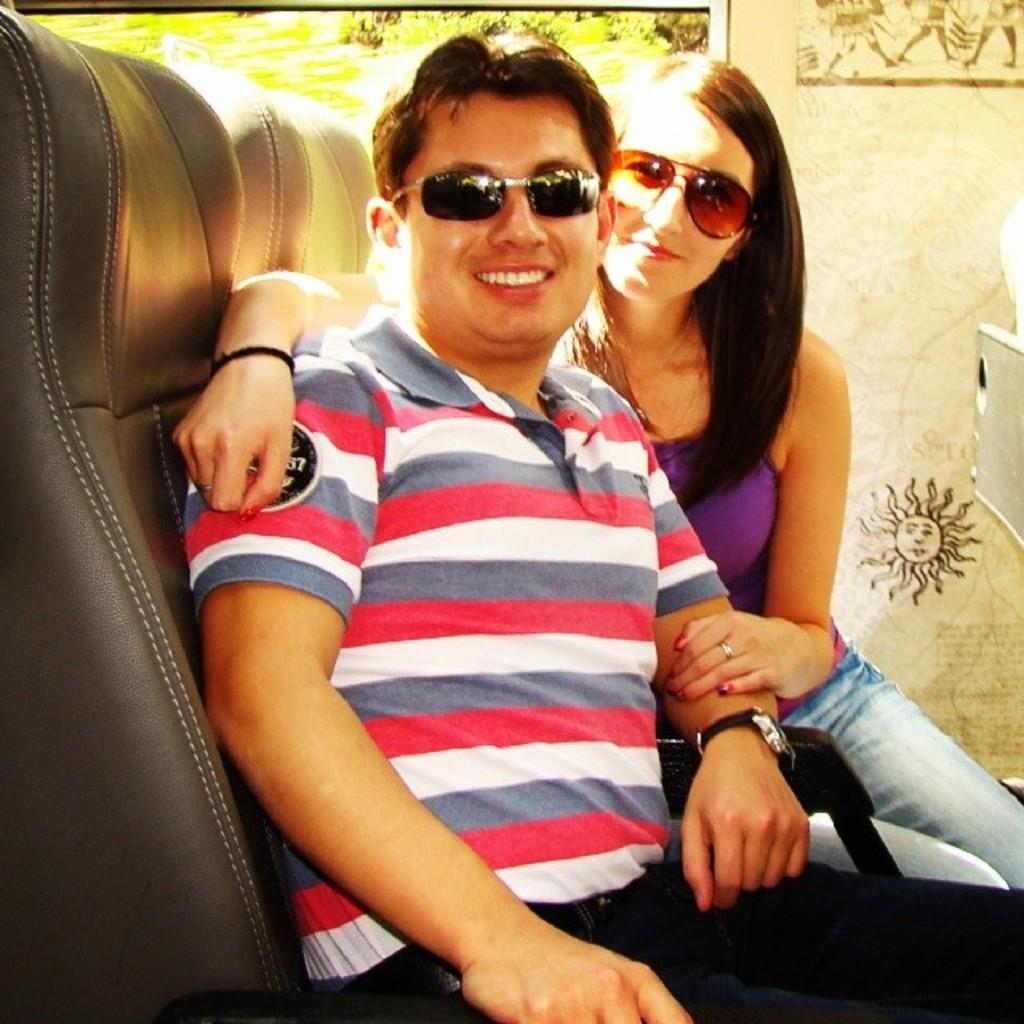Who is present in the image? There is a man and a woman in the image. What are the man and woman doing in the image? Both the man and woman are sitting on chairs. What can be seen on the wall in the image? There is a poster on the wall in the image. What is visible in the background of the image? Trees are visible in the background of the image. How much sugar is on the man's finger in the image? There is no sugar or finger present in the image; the man's hands are not visible. 